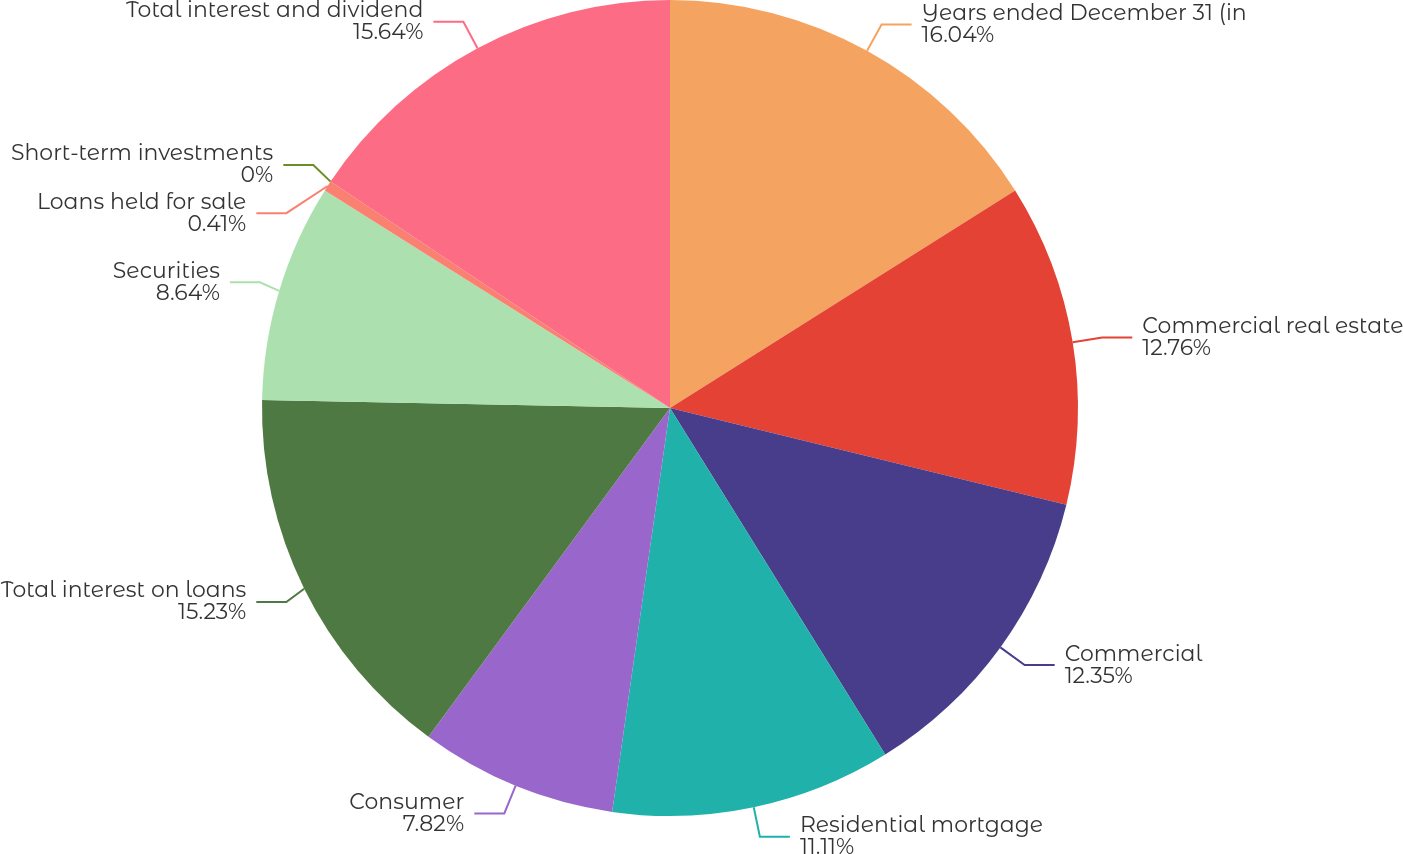<chart> <loc_0><loc_0><loc_500><loc_500><pie_chart><fcel>Years ended December 31 (in<fcel>Commercial real estate<fcel>Commercial<fcel>Residential mortgage<fcel>Consumer<fcel>Total interest on loans<fcel>Securities<fcel>Loans held for sale<fcel>Short-term investments<fcel>Total interest and dividend<nl><fcel>16.05%<fcel>12.76%<fcel>12.35%<fcel>11.11%<fcel>7.82%<fcel>15.23%<fcel>8.64%<fcel>0.41%<fcel>0.0%<fcel>15.64%<nl></chart> 